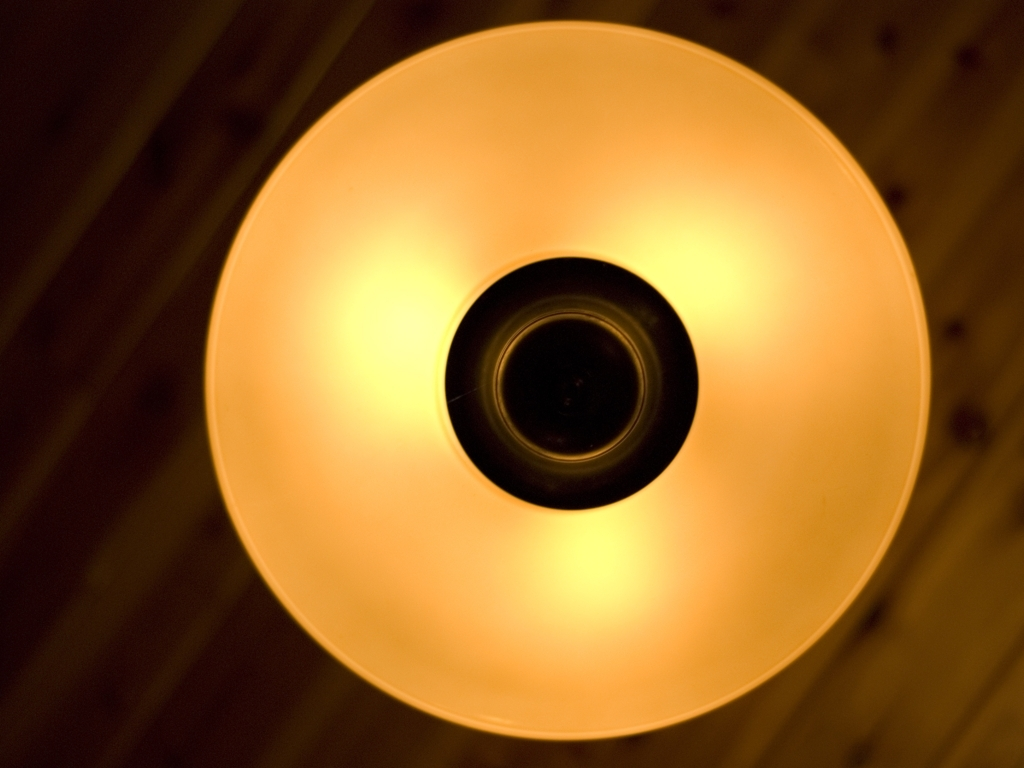Can you describe the design features of the light fixture? Certainly, the light fixture showcases a minimalist and contemporary design. It features a simple, circular shape with a frosted glass diffuser that softens the light. The clean lines and lack of ornamentation suggest a modern aesthetic that values function and understated style. 